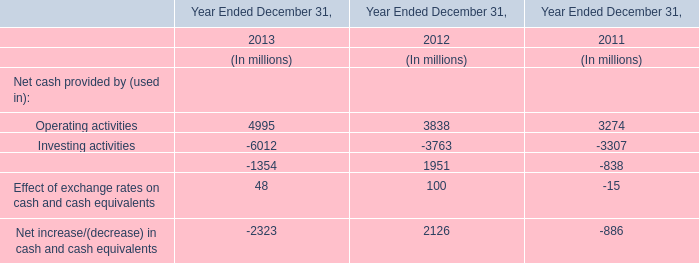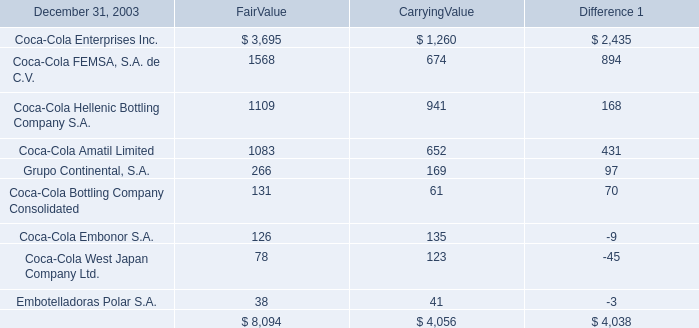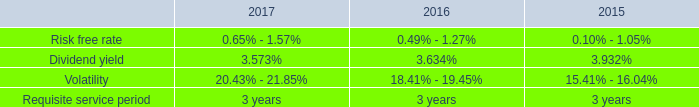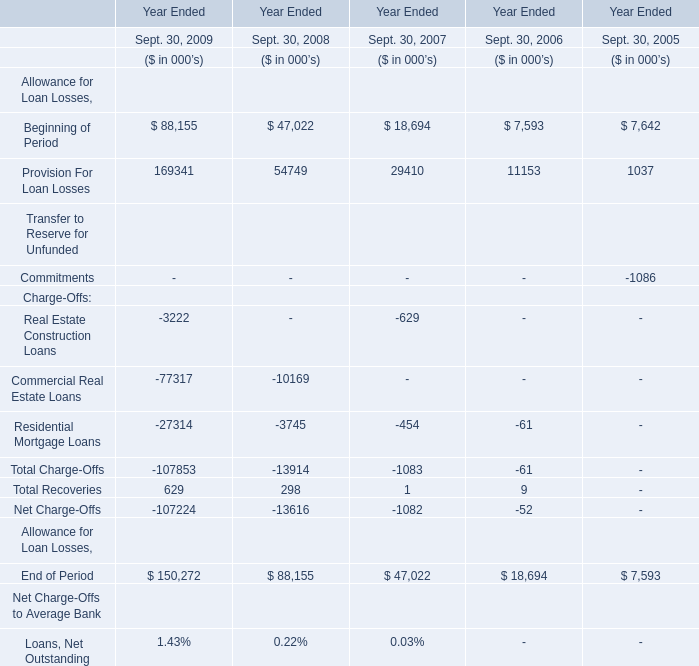what was the percent of the change in the weighted average grant date fair value per share of restricted stock from 2016 to 2017 
Computations: ((84.53 - 73.20) / 73.20)
Answer: 0.15478. 